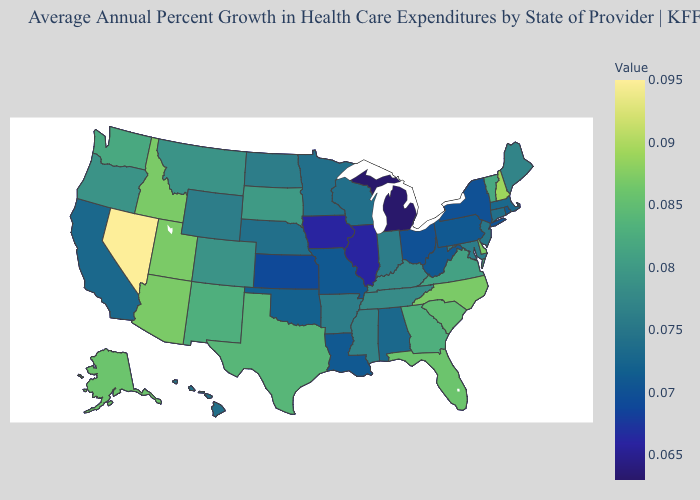Which states have the lowest value in the USA?
Short answer required. Michigan. Does South Dakota have a lower value than Michigan?
Answer briefly. No. Which states have the lowest value in the West?
Quick response, please. California. Among the states that border Utah , which have the lowest value?
Quick response, please. Wyoming. 